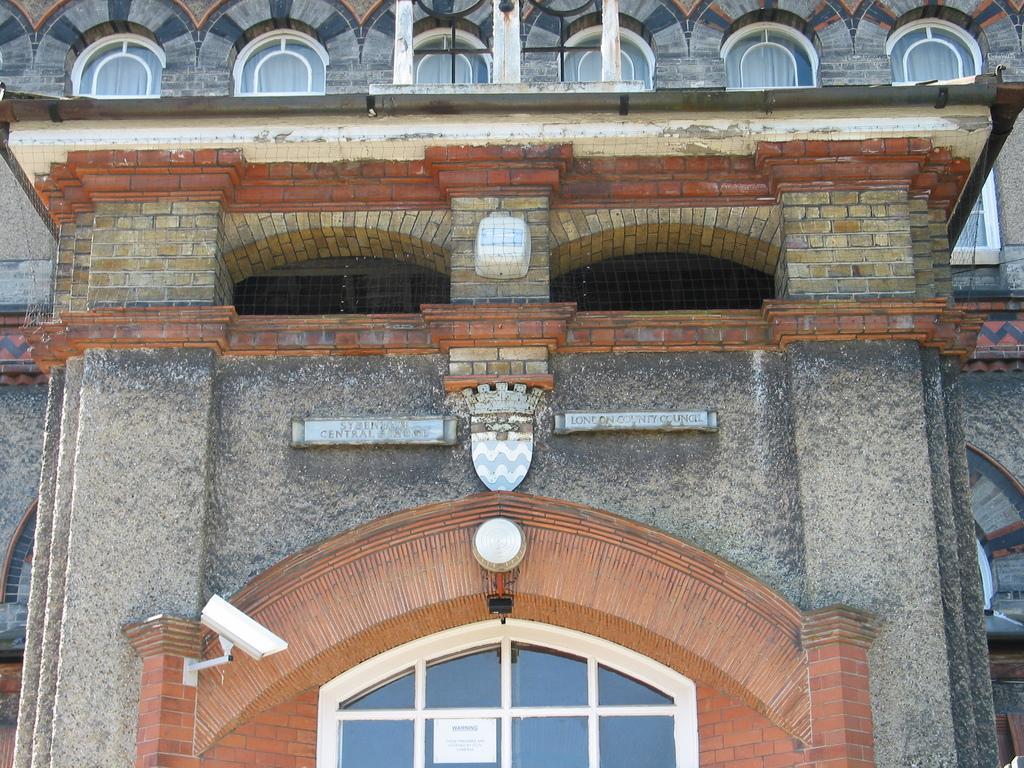Describe this image in one or two sentences. In the picture there is a building, on the building there are glass windows present. 